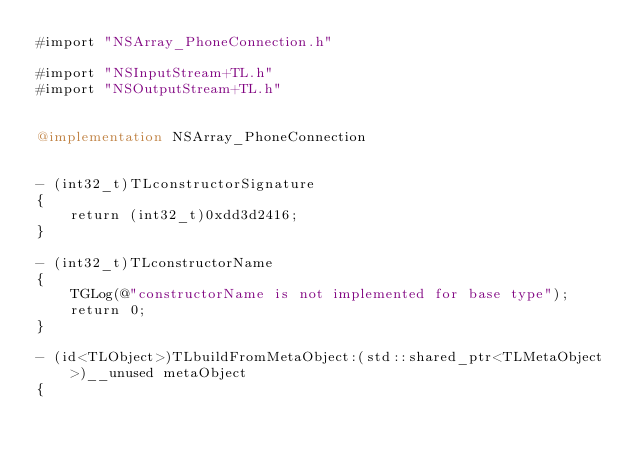<code> <loc_0><loc_0><loc_500><loc_500><_ObjectiveC_>#import "NSArray_PhoneConnection.h"

#import "NSInputStream+TL.h"
#import "NSOutputStream+TL.h"


@implementation NSArray_PhoneConnection


- (int32_t)TLconstructorSignature
{
    return (int32_t)0xdd3d2416;
}

- (int32_t)TLconstructorName
{
    TGLog(@"constructorName is not implemented for base type");
    return 0;
}

- (id<TLObject>)TLbuildFromMetaObject:(std::shared_ptr<TLMetaObject>)__unused metaObject
{</code> 